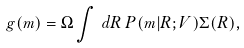Convert formula to latex. <formula><loc_0><loc_0><loc_500><loc_500>g ( m ) = \Omega \int \, d R \, P ( m | R ; V ) \Sigma ( R ) ,</formula> 